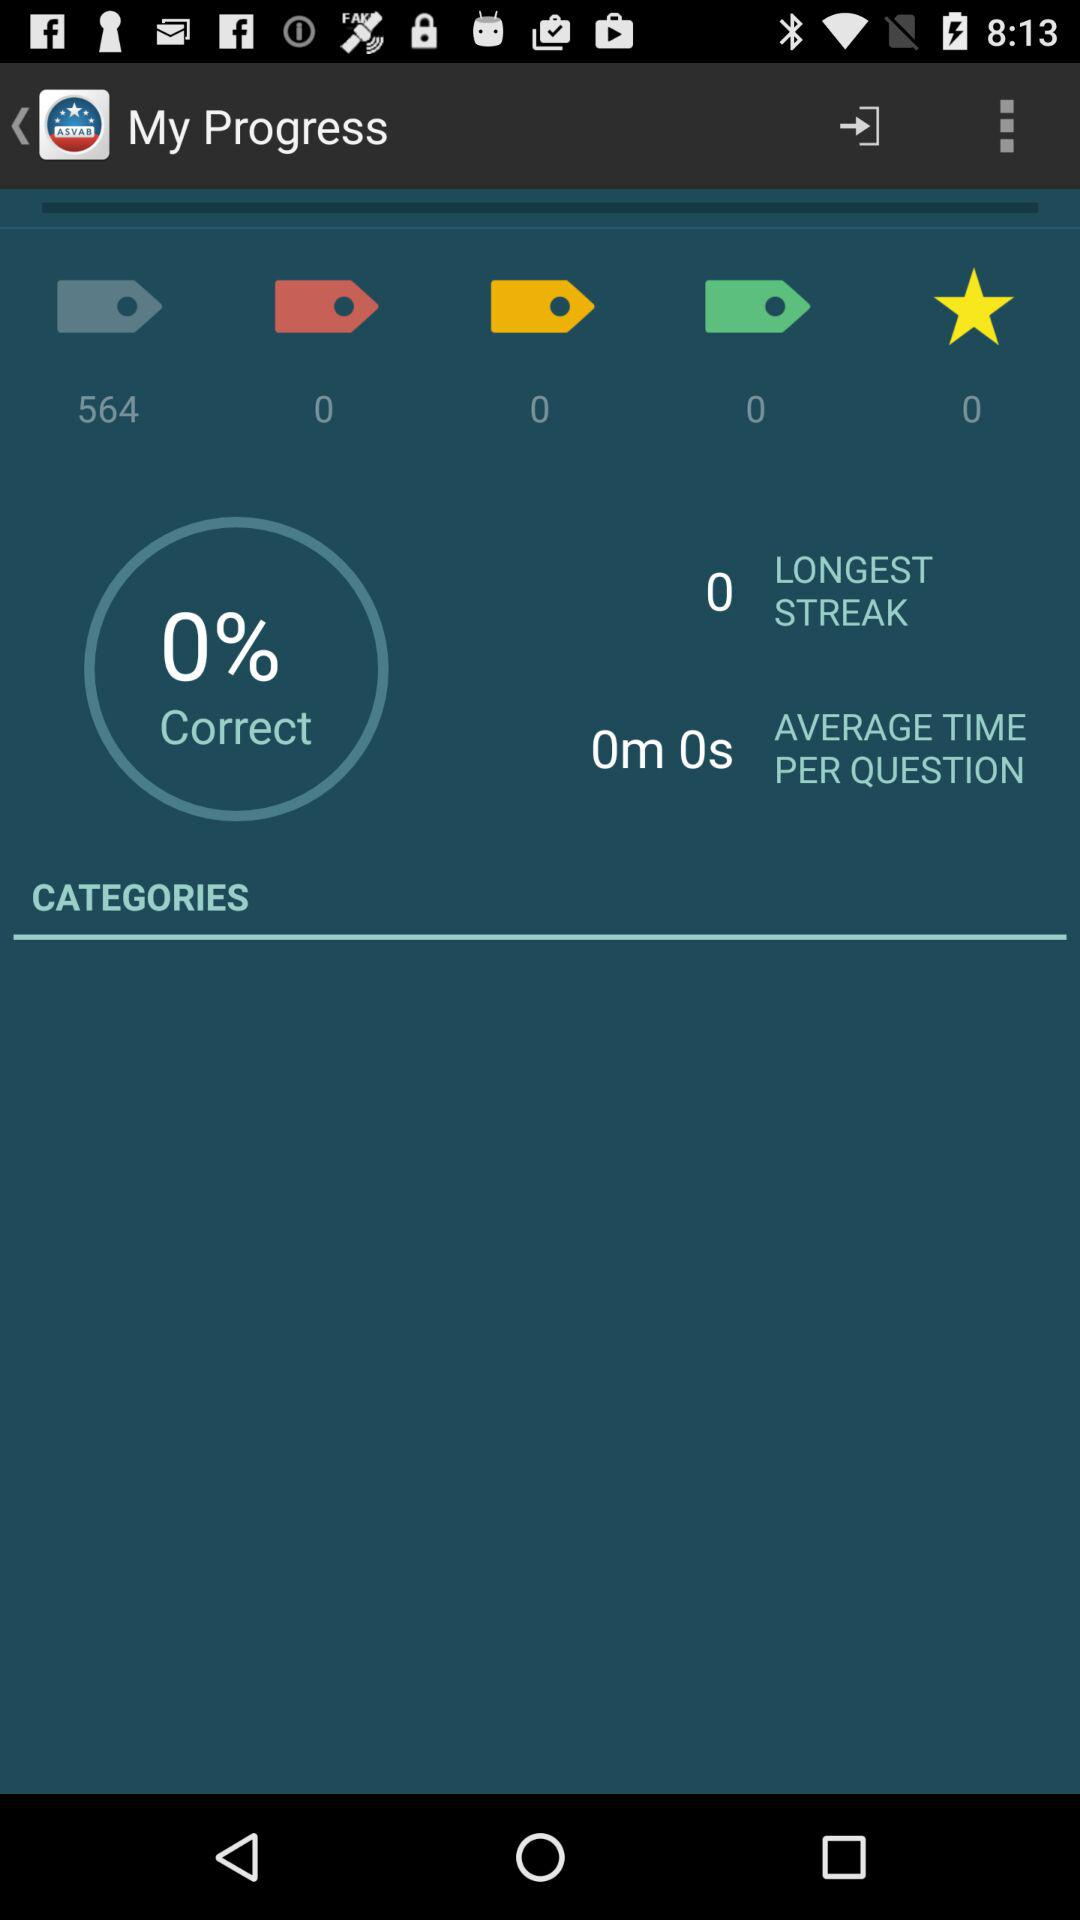What is the average time per question? The average time per question is 0 minutes 0 seconds. 